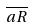Convert formula to latex. <formula><loc_0><loc_0><loc_500><loc_500>\overline { a R }</formula> 